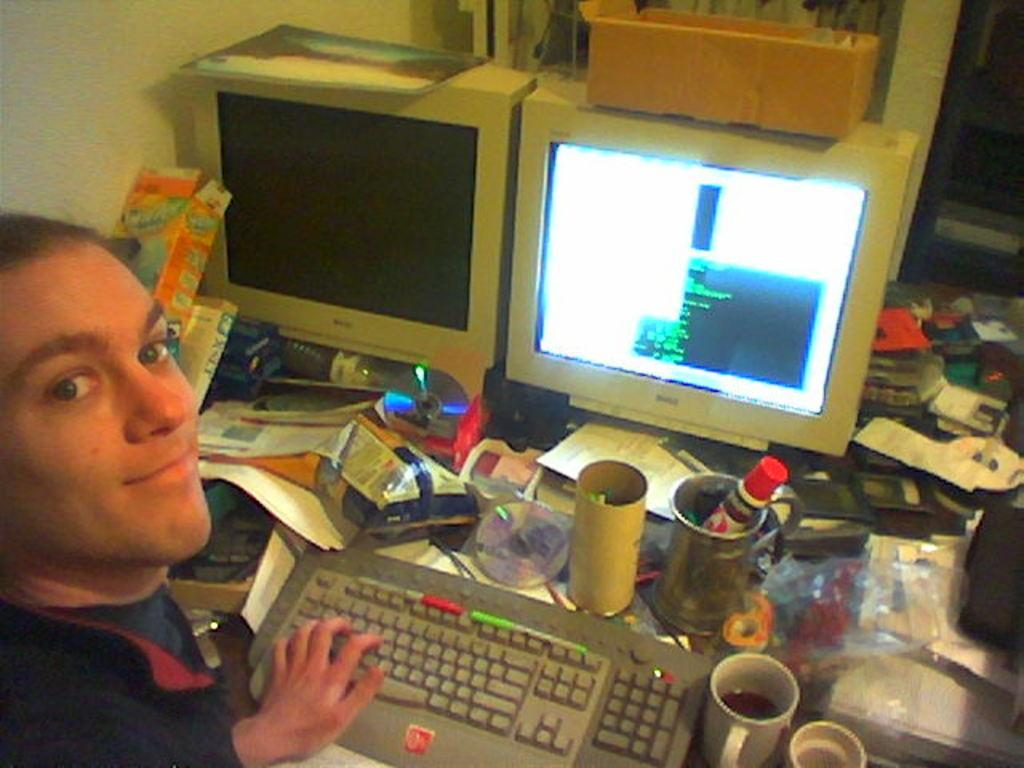Where is the person located in the image? The person is in the left corner of the image. What can be seen on the desktops in the image? There are keyboards on the desktops in the image. What is on the table in the image? There are cups and other objects on the table in the image. What type of basket is hanging on the side of the country in the image? There is no basket or country present in the image. 